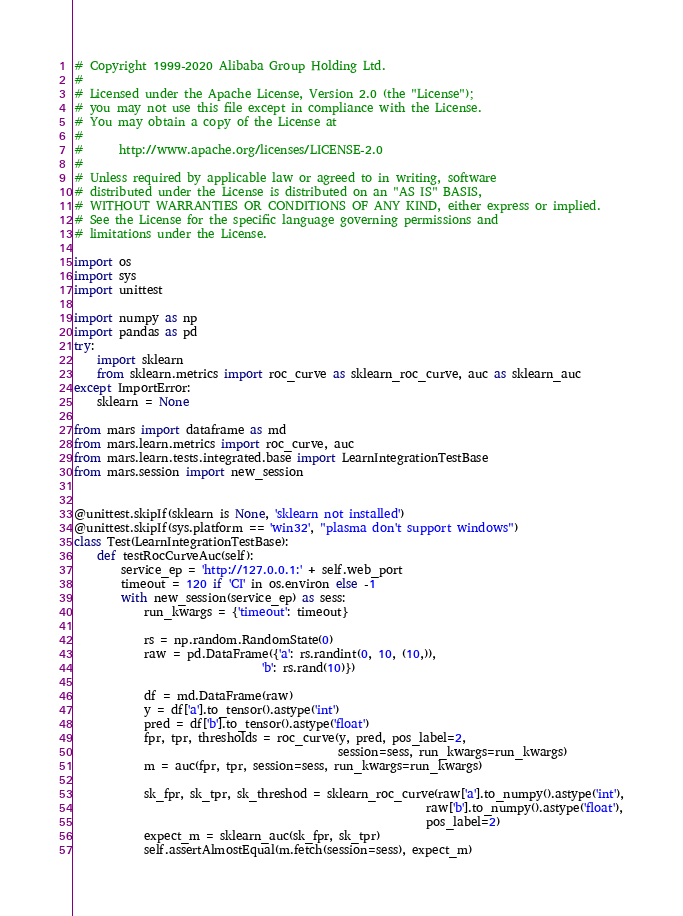Convert code to text. <code><loc_0><loc_0><loc_500><loc_500><_Python_># Copyright 1999-2020 Alibaba Group Holding Ltd.
#
# Licensed under the Apache License, Version 2.0 (the "License");
# you may not use this file except in compliance with the License.
# You may obtain a copy of the License at
#
#      http://www.apache.org/licenses/LICENSE-2.0
#
# Unless required by applicable law or agreed to in writing, software
# distributed under the License is distributed on an "AS IS" BASIS,
# WITHOUT WARRANTIES OR CONDITIONS OF ANY KIND, either express or implied.
# See the License for the specific language governing permissions and
# limitations under the License.

import os
import sys
import unittest

import numpy as np
import pandas as pd
try:
    import sklearn
    from sklearn.metrics import roc_curve as sklearn_roc_curve, auc as sklearn_auc
except ImportError:
    sklearn = None

from mars import dataframe as md
from mars.learn.metrics import roc_curve, auc
from mars.learn.tests.integrated.base import LearnIntegrationTestBase
from mars.session import new_session


@unittest.skipIf(sklearn is None, 'sklearn not installed')
@unittest.skipIf(sys.platform == 'win32', "plasma don't support windows")
class Test(LearnIntegrationTestBase):
    def testRocCurveAuc(self):
        service_ep = 'http://127.0.0.1:' + self.web_port
        timeout = 120 if 'CI' in os.environ else -1
        with new_session(service_ep) as sess:
            run_kwargs = {'timeout': timeout}

            rs = np.random.RandomState(0)
            raw = pd.DataFrame({'a': rs.randint(0, 10, (10,)),
                                'b': rs.rand(10)})

            df = md.DataFrame(raw)
            y = df['a'].to_tensor().astype('int')
            pred = df['b'].to_tensor().astype('float')
            fpr, tpr, thresholds = roc_curve(y, pred, pos_label=2,
                                             session=sess, run_kwargs=run_kwargs)
            m = auc(fpr, tpr, session=sess, run_kwargs=run_kwargs)

            sk_fpr, sk_tpr, sk_threshod = sklearn_roc_curve(raw['a'].to_numpy().astype('int'),
                                                            raw['b'].to_numpy().astype('float'),
                                                            pos_label=2)
            expect_m = sklearn_auc(sk_fpr, sk_tpr)
            self.assertAlmostEqual(m.fetch(session=sess), expect_m)
</code> 